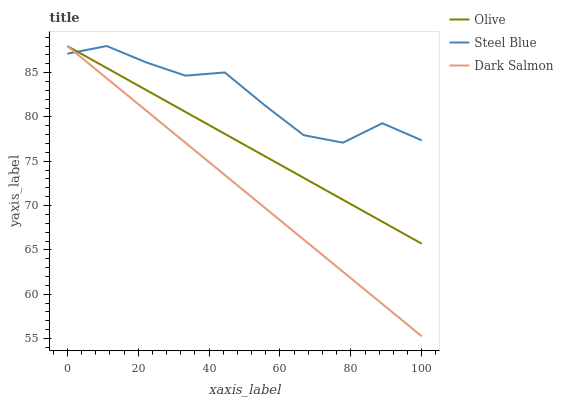Does Dark Salmon have the minimum area under the curve?
Answer yes or no. Yes. Does Steel Blue have the maximum area under the curve?
Answer yes or no. Yes. Does Steel Blue have the minimum area under the curve?
Answer yes or no. No. Does Dark Salmon have the maximum area under the curve?
Answer yes or no. No. Is Dark Salmon the smoothest?
Answer yes or no. Yes. Is Steel Blue the roughest?
Answer yes or no. Yes. Is Steel Blue the smoothest?
Answer yes or no. No. Is Dark Salmon the roughest?
Answer yes or no. No. Does Dark Salmon have the lowest value?
Answer yes or no. Yes. Does Steel Blue have the lowest value?
Answer yes or no. No. Does Dark Salmon have the highest value?
Answer yes or no. Yes. Does Steel Blue intersect Dark Salmon?
Answer yes or no. Yes. Is Steel Blue less than Dark Salmon?
Answer yes or no. No. Is Steel Blue greater than Dark Salmon?
Answer yes or no. No. 